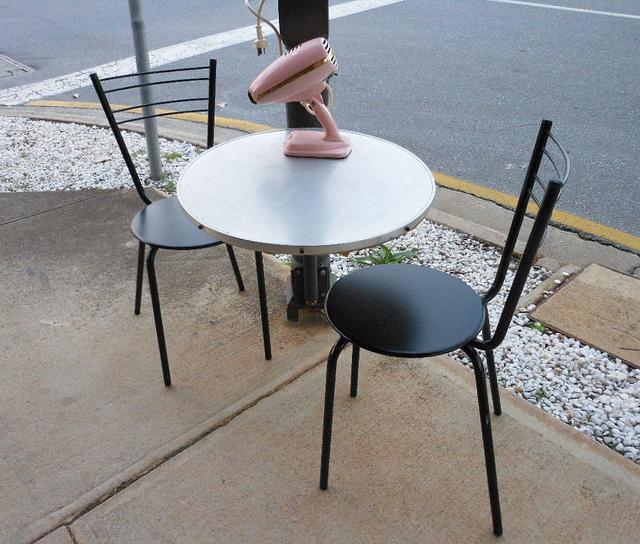What type of electronic is on the table?
Indicate the correct response and explain using: 'Answer: answer
Rationale: rationale.'
Options: Phone, hair dryer, fan, vacuum. Answer: hair dryer.
Rationale: The item sitting on the table is a hair dryer since it has an oblong shape. 